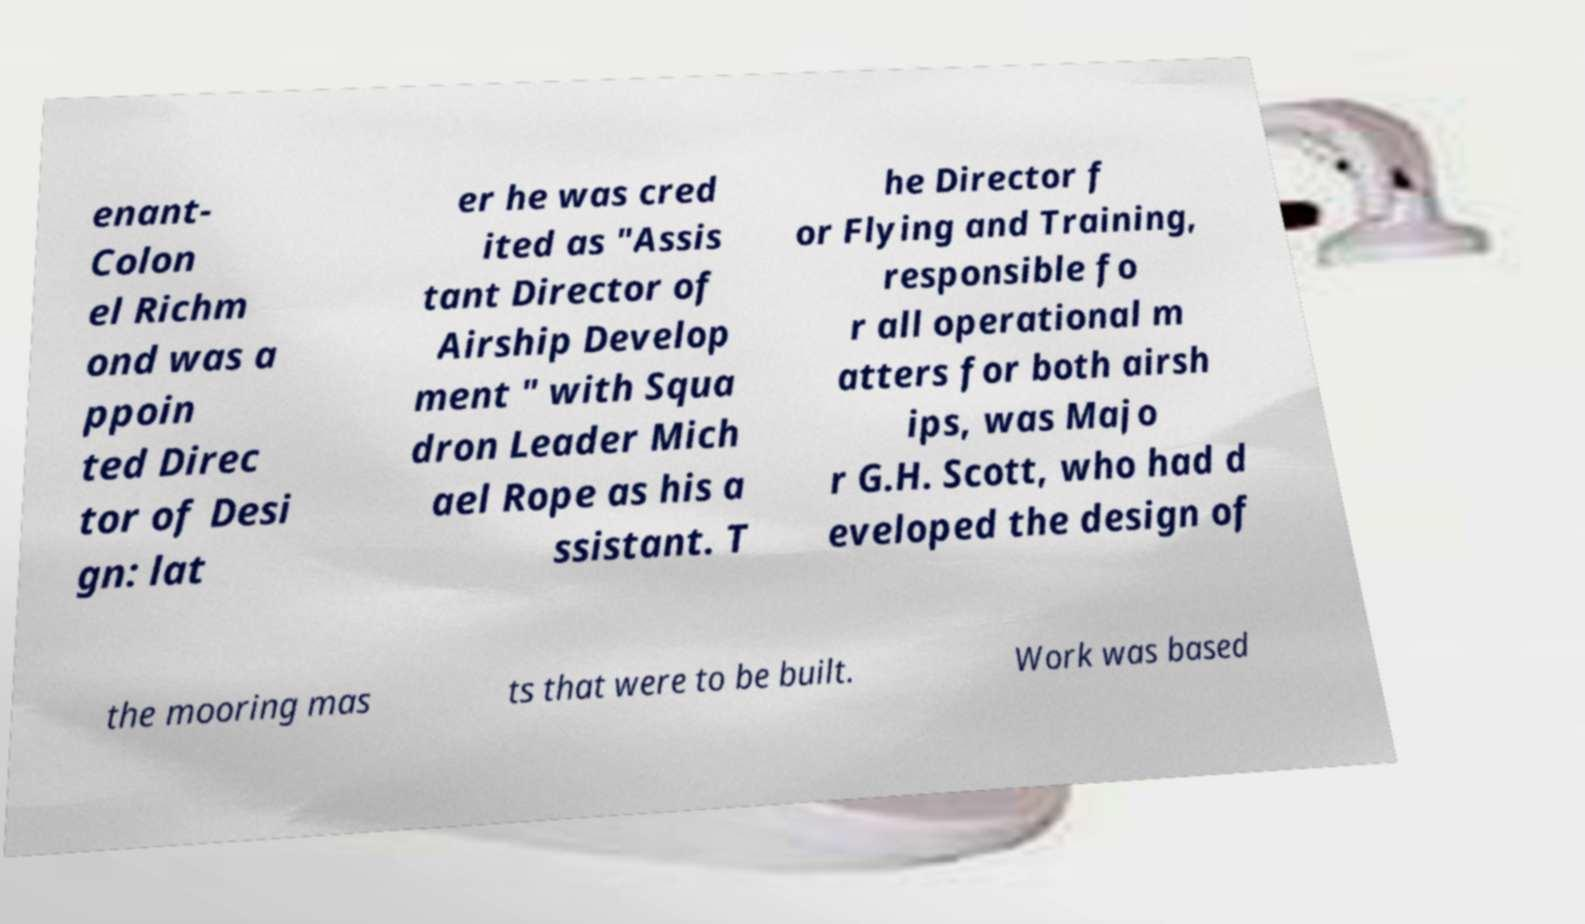Can you accurately transcribe the text from the provided image for me? enant- Colon el Richm ond was a ppoin ted Direc tor of Desi gn: lat er he was cred ited as "Assis tant Director of Airship Develop ment " with Squa dron Leader Mich ael Rope as his a ssistant. T he Director f or Flying and Training, responsible fo r all operational m atters for both airsh ips, was Majo r G.H. Scott, who had d eveloped the design of the mooring mas ts that were to be built. Work was based 